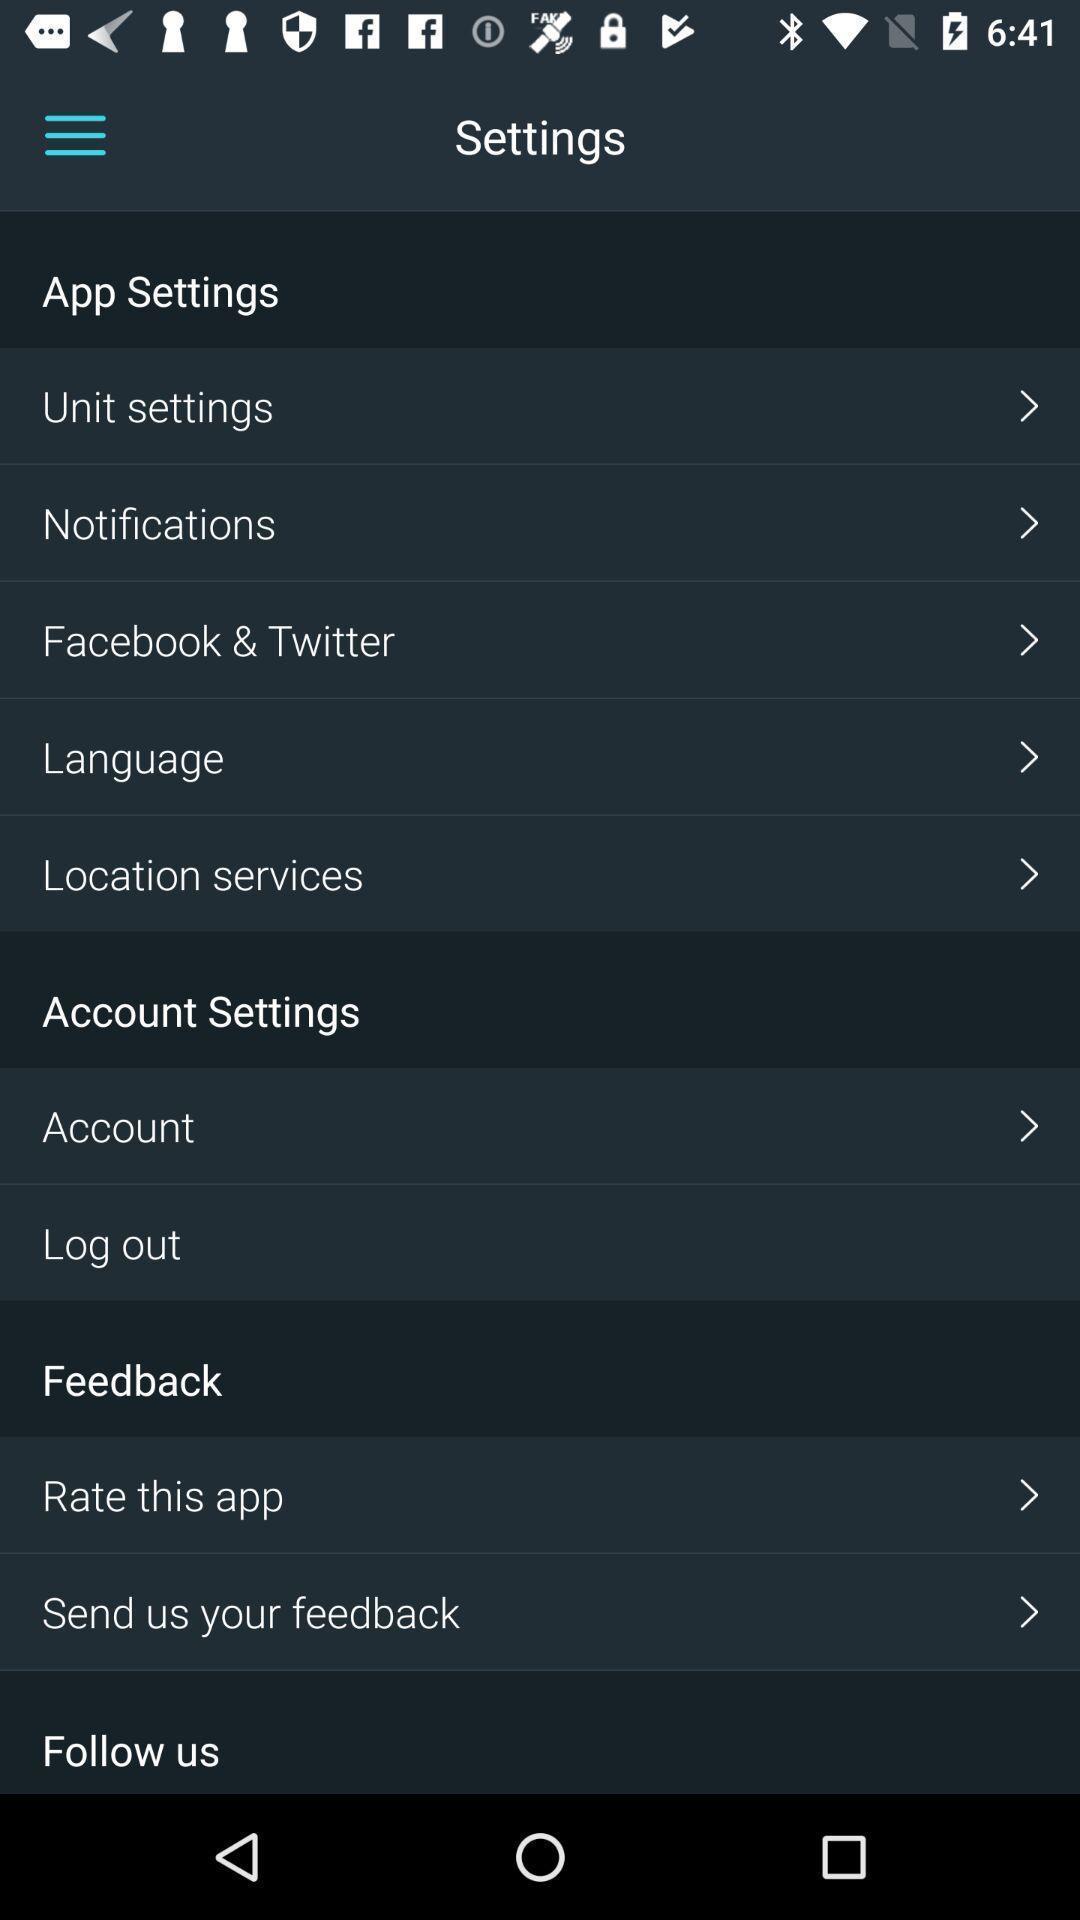Describe this image in words. Settings tab in the mobile with different options. 